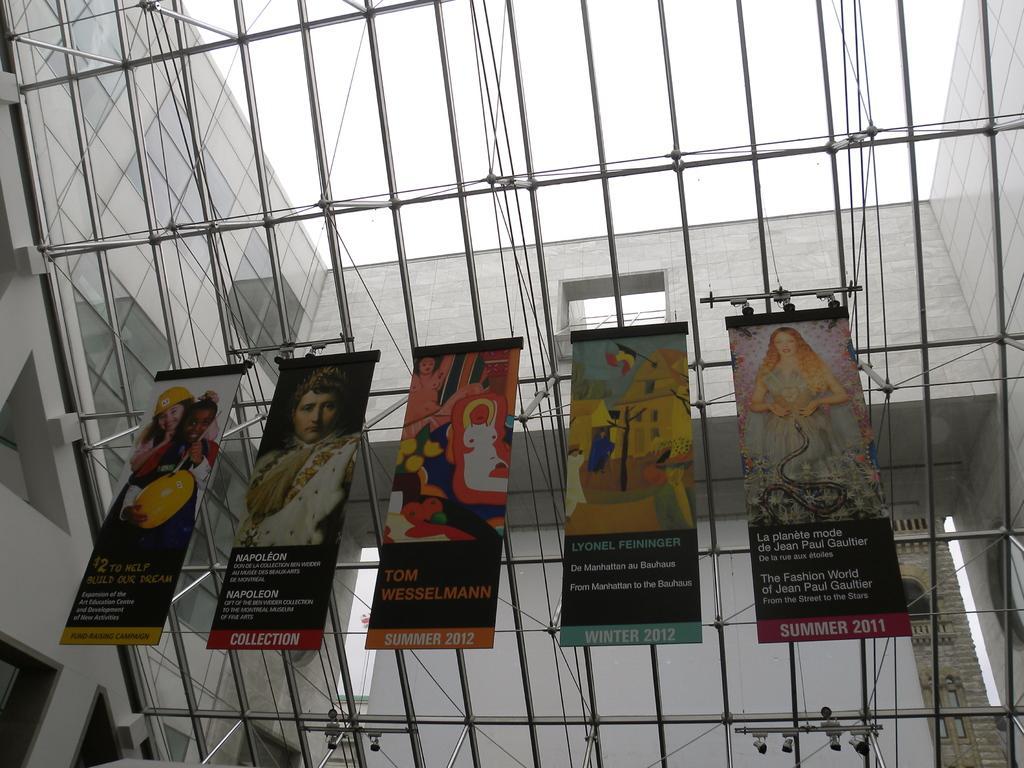Please provide a concise description of this image. In the image we can see five banners and text on them, on it we can even see the pictures of people. Here we can see the internal structure of the building and the sky. 